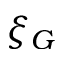Convert formula to latex. <formula><loc_0><loc_0><loc_500><loc_500>\xi _ { G }</formula> 